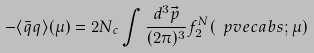Convert formula to latex. <formula><loc_0><loc_0><loc_500><loc_500>- \langle \bar { q } q \rangle ( \mu ) = 2 N _ { c } \int \frac { d ^ { 3 } \vec { p } } { ( 2 \pi ) ^ { 3 } } f _ { 2 } ^ { N } ( \ p v e c a b s ; \mu )</formula> 